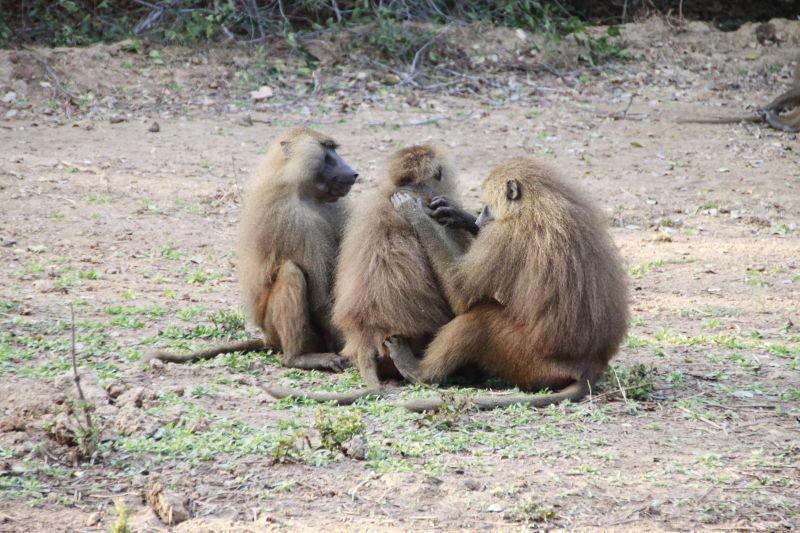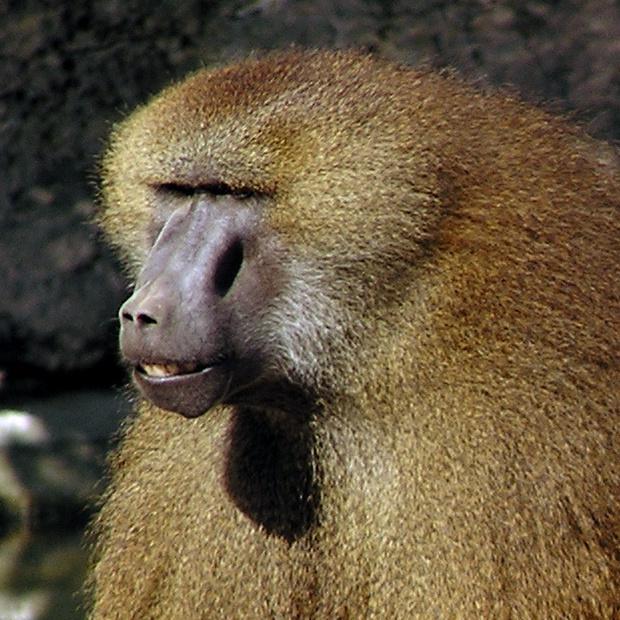The first image is the image on the left, the second image is the image on the right. Analyze the images presented: Is the assertion "The right image contains no more than one baboon." valid? Answer yes or no. Yes. The first image is the image on the left, the second image is the image on the right. For the images shown, is this caption "An image shows a baby baboon clinging, with its body pressed flat, to the back of an adult baboon walking on all fours." true? Answer yes or no. No. 